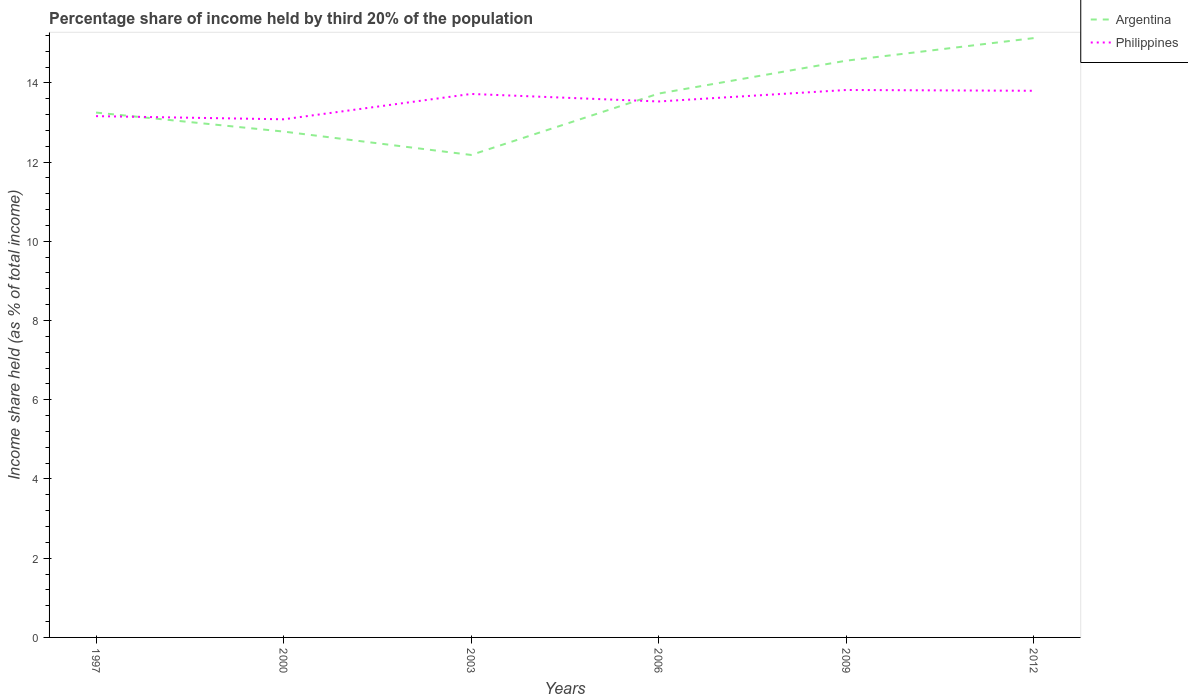How many different coloured lines are there?
Offer a very short reply. 2. Does the line corresponding to Philippines intersect with the line corresponding to Argentina?
Your answer should be compact. Yes. Across all years, what is the maximum share of income held by third 20% of the population in Philippines?
Ensure brevity in your answer.  13.08. What is the total share of income held by third 20% of the population in Philippines in the graph?
Offer a very short reply. -0.29. What is the difference between the highest and the second highest share of income held by third 20% of the population in Argentina?
Give a very brief answer. 2.95. Is the share of income held by third 20% of the population in Argentina strictly greater than the share of income held by third 20% of the population in Philippines over the years?
Ensure brevity in your answer.  No. How many lines are there?
Make the answer very short. 2. What is the difference between two consecutive major ticks on the Y-axis?
Provide a succinct answer. 2. Are the values on the major ticks of Y-axis written in scientific E-notation?
Offer a very short reply. No. Does the graph contain any zero values?
Keep it short and to the point. No. Where does the legend appear in the graph?
Your answer should be compact. Top right. How many legend labels are there?
Offer a terse response. 2. How are the legend labels stacked?
Your response must be concise. Vertical. What is the title of the graph?
Offer a terse response. Percentage share of income held by third 20% of the population. Does "Swaziland" appear as one of the legend labels in the graph?
Your answer should be very brief. No. What is the label or title of the X-axis?
Your answer should be compact. Years. What is the label or title of the Y-axis?
Your response must be concise. Income share held (as % of total income). What is the Income share held (as % of total income) of Argentina in 1997?
Your answer should be compact. 13.25. What is the Income share held (as % of total income) in Philippines in 1997?
Your answer should be very brief. 13.16. What is the Income share held (as % of total income) of Argentina in 2000?
Ensure brevity in your answer.  12.77. What is the Income share held (as % of total income) in Philippines in 2000?
Give a very brief answer. 13.08. What is the Income share held (as % of total income) in Argentina in 2003?
Your answer should be very brief. 12.18. What is the Income share held (as % of total income) in Philippines in 2003?
Ensure brevity in your answer.  13.72. What is the Income share held (as % of total income) in Argentina in 2006?
Ensure brevity in your answer.  13.73. What is the Income share held (as % of total income) in Philippines in 2006?
Keep it short and to the point. 13.53. What is the Income share held (as % of total income) in Argentina in 2009?
Offer a terse response. 14.56. What is the Income share held (as % of total income) in Philippines in 2009?
Provide a short and direct response. 13.82. What is the Income share held (as % of total income) in Argentina in 2012?
Give a very brief answer. 15.13. What is the Income share held (as % of total income) in Philippines in 2012?
Ensure brevity in your answer.  13.8. Across all years, what is the maximum Income share held (as % of total income) in Argentina?
Provide a short and direct response. 15.13. Across all years, what is the maximum Income share held (as % of total income) of Philippines?
Provide a short and direct response. 13.82. Across all years, what is the minimum Income share held (as % of total income) of Argentina?
Keep it short and to the point. 12.18. Across all years, what is the minimum Income share held (as % of total income) of Philippines?
Ensure brevity in your answer.  13.08. What is the total Income share held (as % of total income) in Argentina in the graph?
Offer a terse response. 81.62. What is the total Income share held (as % of total income) in Philippines in the graph?
Provide a short and direct response. 81.11. What is the difference between the Income share held (as % of total income) in Argentina in 1997 and that in 2000?
Ensure brevity in your answer.  0.48. What is the difference between the Income share held (as % of total income) of Philippines in 1997 and that in 2000?
Offer a very short reply. 0.08. What is the difference between the Income share held (as % of total income) in Argentina in 1997 and that in 2003?
Provide a succinct answer. 1.07. What is the difference between the Income share held (as % of total income) of Philippines in 1997 and that in 2003?
Ensure brevity in your answer.  -0.56. What is the difference between the Income share held (as % of total income) in Argentina in 1997 and that in 2006?
Give a very brief answer. -0.48. What is the difference between the Income share held (as % of total income) in Philippines in 1997 and that in 2006?
Provide a short and direct response. -0.37. What is the difference between the Income share held (as % of total income) of Argentina in 1997 and that in 2009?
Your answer should be very brief. -1.31. What is the difference between the Income share held (as % of total income) in Philippines in 1997 and that in 2009?
Provide a short and direct response. -0.66. What is the difference between the Income share held (as % of total income) of Argentina in 1997 and that in 2012?
Provide a succinct answer. -1.88. What is the difference between the Income share held (as % of total income) of Philippines in 1997 and that in 2012?
Ensure brevity in your answer.  -0.64. What is the difference between the Income share held (as % of total income) in Argentina in 2000 and that in 2003?
Your response must be concise. 0.59. What is the difference between the Income share held (as % of total income) in Philippines in 2000 and that in 2003?
Give a very brief answer. -0.64. What is the difference between the Income share held (as % of total income) of Argentina in 2000 and that in 2006?
Your answer should be very brief. -0.96. What is the difference between the Income share held (as % of total income) in Philippines in 2000 and that in 2006?
Provide a short and direct response. -0.45. What is the difference between the Income share held (as % of total income) of Argentina in 2000 and that in 2009?
Your answer should be very brief. -1.79. What is the difference between the Income share held (as % of total income) of Philippines in 2000 and that in 2009?
Your response must be concise. -0.74. What is the difference between the Income share held (as % of total income) of Argentina in 2000 and that in 2012?
Provide a short and direct response. -2.36. What is the difference between the Income share held (as % of total income) in Philippines in 2000 and that in 2012?
Provide a short and direct response. -0.72. What is the difference between the Income share held (as % of total income) in Argentina in 2003 and that in 2006?
Make the answer very short. -1.55. What is the difference between the Income share held (as % of total income) in Philippines in 2003 and that in 2006?
Offer a terse response. 0.19. What is the difference between the Income share held (as % of total income) of Argentina in 2003 and that in 2009?
Your answer should be compact. -2.38. What is the difference between the Income share held (as % of total income) in Argentina in 2003 and that in 2012?
Ensure brevity in your answer.  -2.95. What is the difference between the Income share held (as % of total income) of Philippines in 2003 and that in 2012?
Make the answer very short. -0.08. What is the difference between the Income share held (as % of total income) in Argentina in 2006 and that in 2009?
Offer a terse response. -0.83. What is the difference between the Income share held (as % of total income) in Philippines in 2006 and that in 2009?
Your answer should be very brief. -0.29. What is the difference between the Income share held (as % of total income) in Philippines in 2006 and that in 2012?
Make the answer very short. -0.27. What is the difference between the Income share held (as % of total income) of Argentina in 2009 and that in 2012?
Your answer should be very brief. -0.57. What is the difference between the Income share held (as % of total income) in Philippines in 2009 and that in 2012?
Your answer should be very brief. 0.02. What is the difference between the Income share held (as % of total income) in Argentina in 1997 and the Income share held (as % of total income) in Philippines in 2000?
Make the answer very short. 0.17. What is the difference between the Income share held (as % of total income) in Argentina in 1997 and the Income share held (as % of total income) in Philippines in 2003?
Ensure brevity in your answer.  -0.47. What is the difference between the Income share held (as % of total income) in Argentina in 1997 and the Income share held (as % of total income) in Philippines in 2006?
Make the answer very short. -0.28. What is the difference between the Income share held (as % of total income) in Argentina in 1997 and the Income share held (as % of total income) in Philippines in 2009?
Provide a short and direct response. -0.57. What is the difference between the Income share held (as % of total income) of Argentina in 1997 and the Income share held (as % of total income) of Philippines in 2012?
Your response must be concise. -0.55. What is the difference between the Income share held (as % of total income) of Argentina in 2000 and the Income share held (as % of total income) of Philippines in 2003?
Give a very brief answer. -0.95. What is the difference between the Income share held (as % of total income) of Argentina in 2000 and the Income share held (as % of total income) of Philippines in 2006?
Ensure brevity in your answer.  -0.76. What is the difference between the Income share held (as % of total income) in Argentina in 2000 and the Income share held (as % of total income) in Philippines in 2009?
Provide a short and direct response. -1.05. What is the difference between the Income share held (as % of total income) of Argentina in 2000 and the Income share held (as % of total income) of Philippines in 2012?
Give a very brief answer. -1.03. What is the difference between the Income share held (as % of total income) in Argentina in 2003 and the Income share held (as % of total income) in Philippines in 2006?
Offer a terse response. -1.35. What is the difference between the Income share held (as % of total income) of Argentina in 2003 and the Income share held (as % of total income) of Philippines in 2009?
Provide a succinct answer. -1.64. What is the difference between the Income share held (as % of total income) of Argentina in 2003 and the Income share held (as % of total income) of Philippines in 2012?
Ensure brevity in your answer.  -1.62. What is the difference between the Income share held (as % of total income) of Argentina in 2006 and the Income share held (as % of total income) of Philippines in 2009?
Your answer should be compact. -0.09. What is the difference between the Income share held (as % of total income) of Argentina in 2006 and the Income share held (as % of total income) of Philippines in 2012?
Your response must be concise. -0.07. What is the difference between the Income share held (as % of total income) in Argentina in 2009 and the Income share held (as % of total income) in Philippines in 2012?
Give a very brief answer. 0.76. What is the average Income share held (as % of total income) of Argentina per year?
Your answer should be compact. 13.6. What is the average Income share held (as % of total income) of Philippines per year?
Keep it short and to the point. 13.52. In the year 1997, what is the difference between the Income share held (as % of total income) in Argentina and Income share held (as % of total income) in Philippines?
Offer a very short reply. 0.09. In the year 2000, what is the difference between the Income share held (as % of total income) of Argentina and Income share held (as % of total income) of Philippines?
Give a very brief answer. -0.31. In the year 2003, what is the difference between the Income share held (as % of total income) in Argentina and Income share held (as % of total income) in Philippines?
Your response must be concise. -1.54. In the year 2006, what is the difference between the Income share held (as % of total income) of Argentina and Income share held (as % of total income) of Philippines?
Make the answer very short. 0.2. In the year 2009, what is the difference between the Income share held (as % of total income) in Argentina and Income share held (as % of total income) in Philippines?
Offer a terse response. 0.74. In the year 2012, what is the difference between the Income share held (as % of total income) of Argentina and Income share held (as % of total income) of Philippines?
Offer a terse response. 1.33. What is the ratio of the Income share held (as % of total income) of Argentina in 1997 to that in 2000?
Provide a succinct answer. 1.04. What is the ratio of the Income share held (as % of total income) of Argentina in 1997 to that in 2003?
Ensure brevity in your answer.  1.09. What is the ratio of the Income share held (as % of total income) in Philippines in 1997 to that in 2003?
Keep it short and to the point. 0.96. What is the ratio of the Income share held (as % of total income) of Argentina in 1997 to that in 2006?
Ensure brevity in your answer.  0.96. What is the ratio of the Income share held (as % of total income) in Philippines in 1997 to that in 2006?
Your response must be concise. 0.97. What is the ratio of the Income share held (as % of total income) of Argentina in 1997 to that in 2009?
Ensure brevity in your answer.  0.91. What is the ratio of the Income share held (as % of total income) in Philippines in 1997 to that in 2009?
Give a very brief answer. 0.95. What is the ratio of the Income share held (as % of total income) in Argentina in 1997 to that in 2012?
Keep it short and to the point. 0.88. What is the ratio of the Income share held (as % of total income) of Philippines in 1997 to that in 2012?
Keep it short and to the point. 0.95. What is the ratio of the Income share held (as % of total income) of Argentina in 2000 to that in 2003?
Provide a succinct answer. 1.05. What is the ratio of the Income share held (as % of total income) of Philippines in 2000 to that in 2003?
Give a very brief answer. 0.95. What is the ratio of the Income share held (as % of total income) in Argentina in 2000 to that in 2006?
Provide a short and direct response. 0.93. What is the ratio of the Income share held (as % of total income) in Philippines in 2000 to that in 2006?
Keep it short and to the point. 0.97. What is the ratio of the Income share held (as % of total income) in Argentina in 2000 to that in 2009?
Give a very brief answer. 0.88. What is the ratio of the Income share held (as % of total income) of Philippines in 2000 to that in 2009?
Offer a terse response. 0.95. What is the ratio of the Income share held (as % of total income) in Argentina in 2000 to that in 2012?
Your answer should be very brief. 0.84. What is the ratio of the Income share held (as % of total income) in Philippines in 2000 to that in 2012?
Keep it short and to the point. 0.95. What is the ratio of the Income share held (as % of total income) in Argentina in 2003 to that in 2006?
Your answer should be compact. 0.89. What is the ratio of the Income share held (as % of total income) in Argentina in 2003 to that in 2009?
Your answer should be compact. 0.84. What is the ratio of the Income share held (as % of total income) in Argentina in 2003 to that in 2012?
Your answer should be very brief. 0.81. What is the ratio of the Income share held (as % of total income) in Philippines in 2003 to that in 2012?
Provide a succinct answer. 0.99. What is the ratio of the Income share held (as % of total income) in Argentina in 2006 to that in 2009?
Make the answer very short. 0.94. What is the ratio of the Income share held (as % of total income) of Argentina in 2006 to that in 2012?
Provide a succinct answer. 0.91. What is the ratio of the Income share held (as % of total income) in Philippines in 2006 to that in 2012?
Offer a terse response. 0.98. What is the ratio of the Income share held (as % of total income) in Argentina in 2009 to that in 2012?
Give a very brief answer. 0.96. What is the difference between the highest and the second highest Income share held (as % of total income) in Argentina?
Make the answer very short. 0.57. What is the difference between the highest and the second highest Income share held (as % of total income) of Philippines?
Keep it short and to the point. 0.02. What is the difference between the highest and the lowest Income share held (as % of total income) in Argentina?
Offer a terse response. 2.95. What is the difference between the highest and the lowest Income share held (as % of total income) in Philippines?
Offer a terse response. 0.74. 